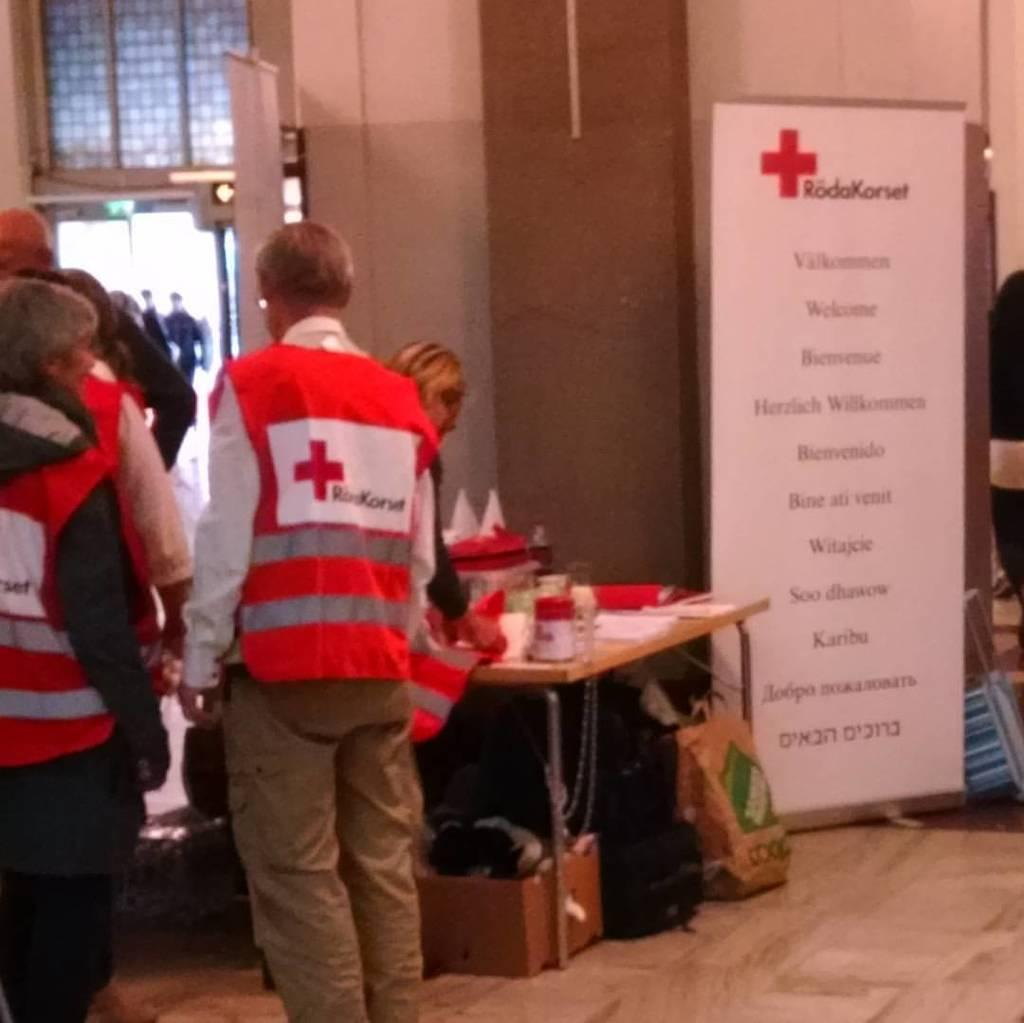What type of furniture is visible in the image? There is a table in the image. What is on the table in the image? Medical equipment is present on the table. Can you describe the people in the image? There is a group of people standing in the image. How many pigs are visible in the image? There are no pigs present in the image. What type of lamp is being used by the people in the image? There is no lamp present in the image. 